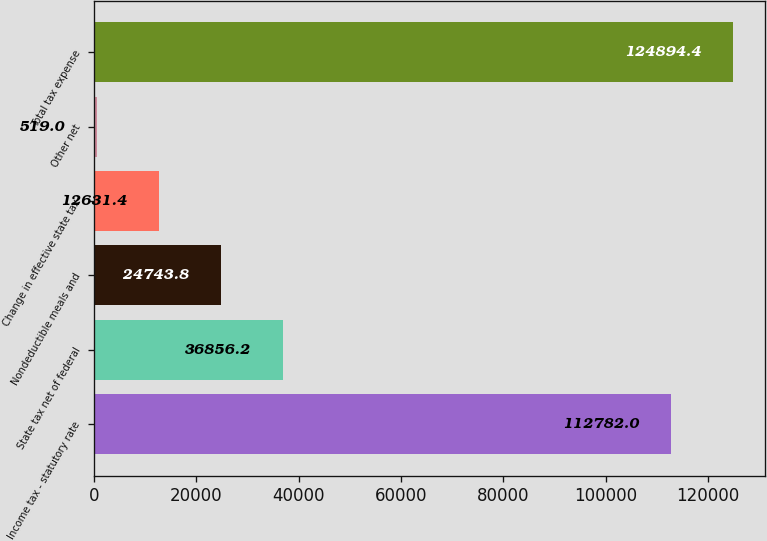Convert chart. <chart><loc_0><loc_0><loc_500><loc_500><bar_chart><fcel>Income tax - statutory rate<fcel>State tax net of federal<fcel>Nondeductible meals and<fcel>Change in effective state tax<fcel>Other net<fcel>Total tax expense<nl><fcel>112782<fcel>36856.2<fcel>24743.8<fcel>12631.4<fcel>519<fcel>124894<nl></chart> 